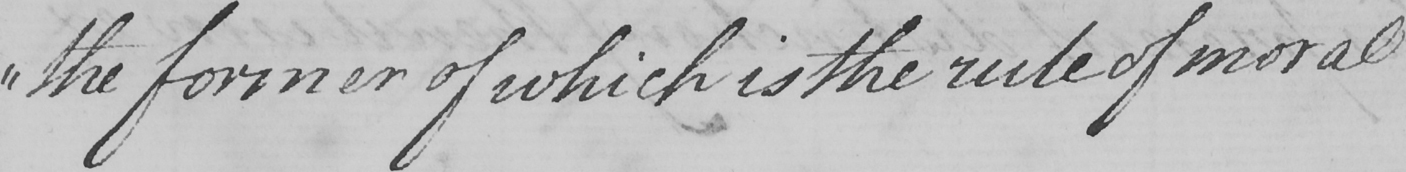Please provide the text content of this handwritten line. " the former of which is the rule of moral 